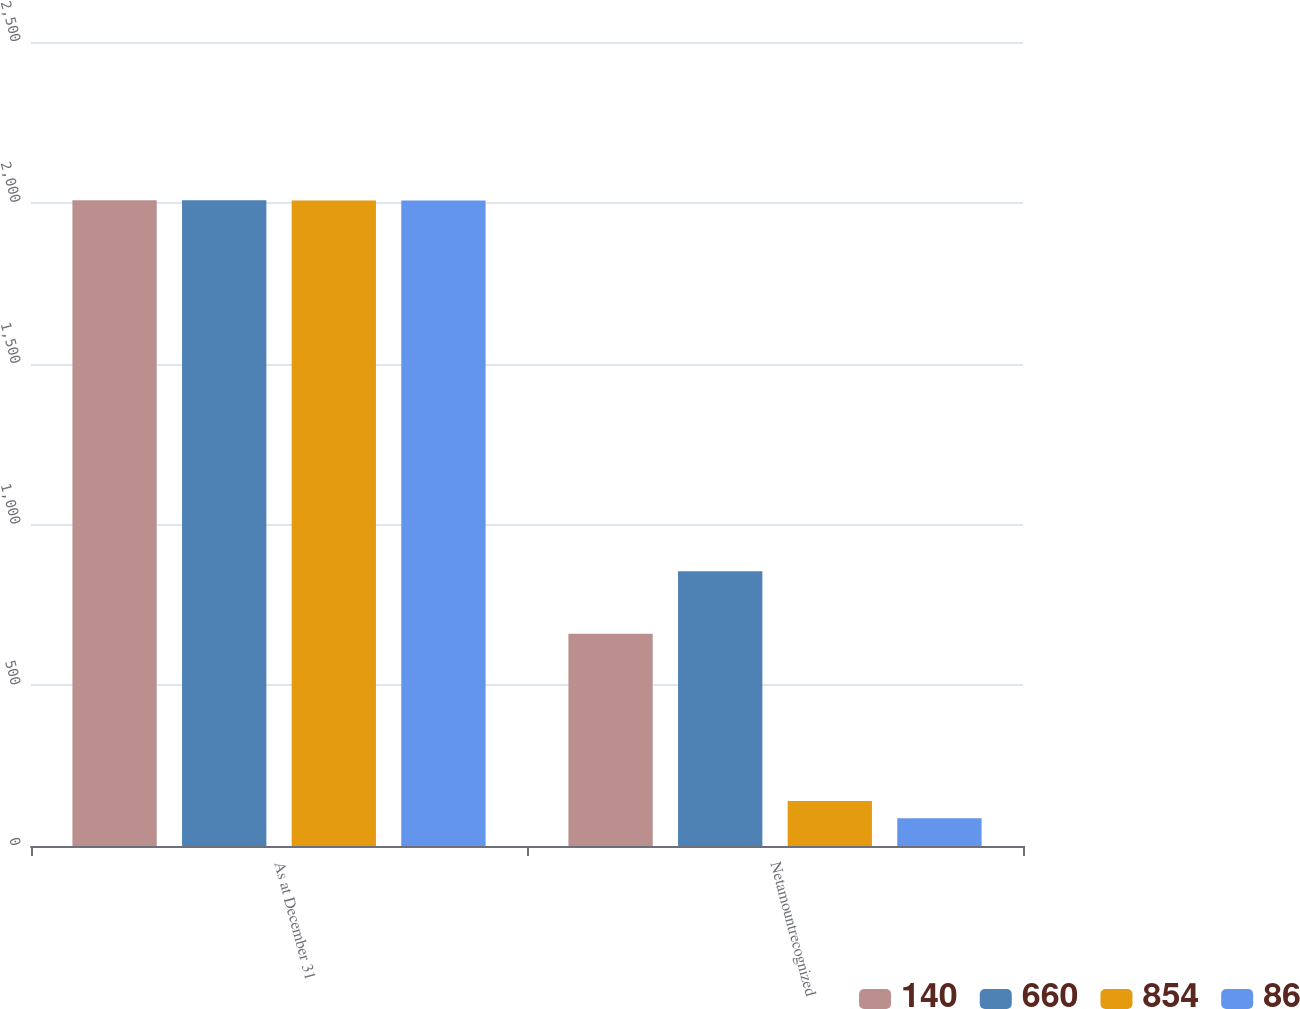Convert chart. <chart><loc_0><loc_0><loc_500><loc_500><stacked_bar_chart><ecel><fcel>As at December 31<fcel>Netamountrecognized<nl><fcel>140<fcel>2008<fcel>660<nl><fcel>660<fcel>2008<fcel>854<nl><fcel>854<fcel>2007<fcel>140<nl><fcel>86<fcel>2007<fcel>86<nl></chart> 